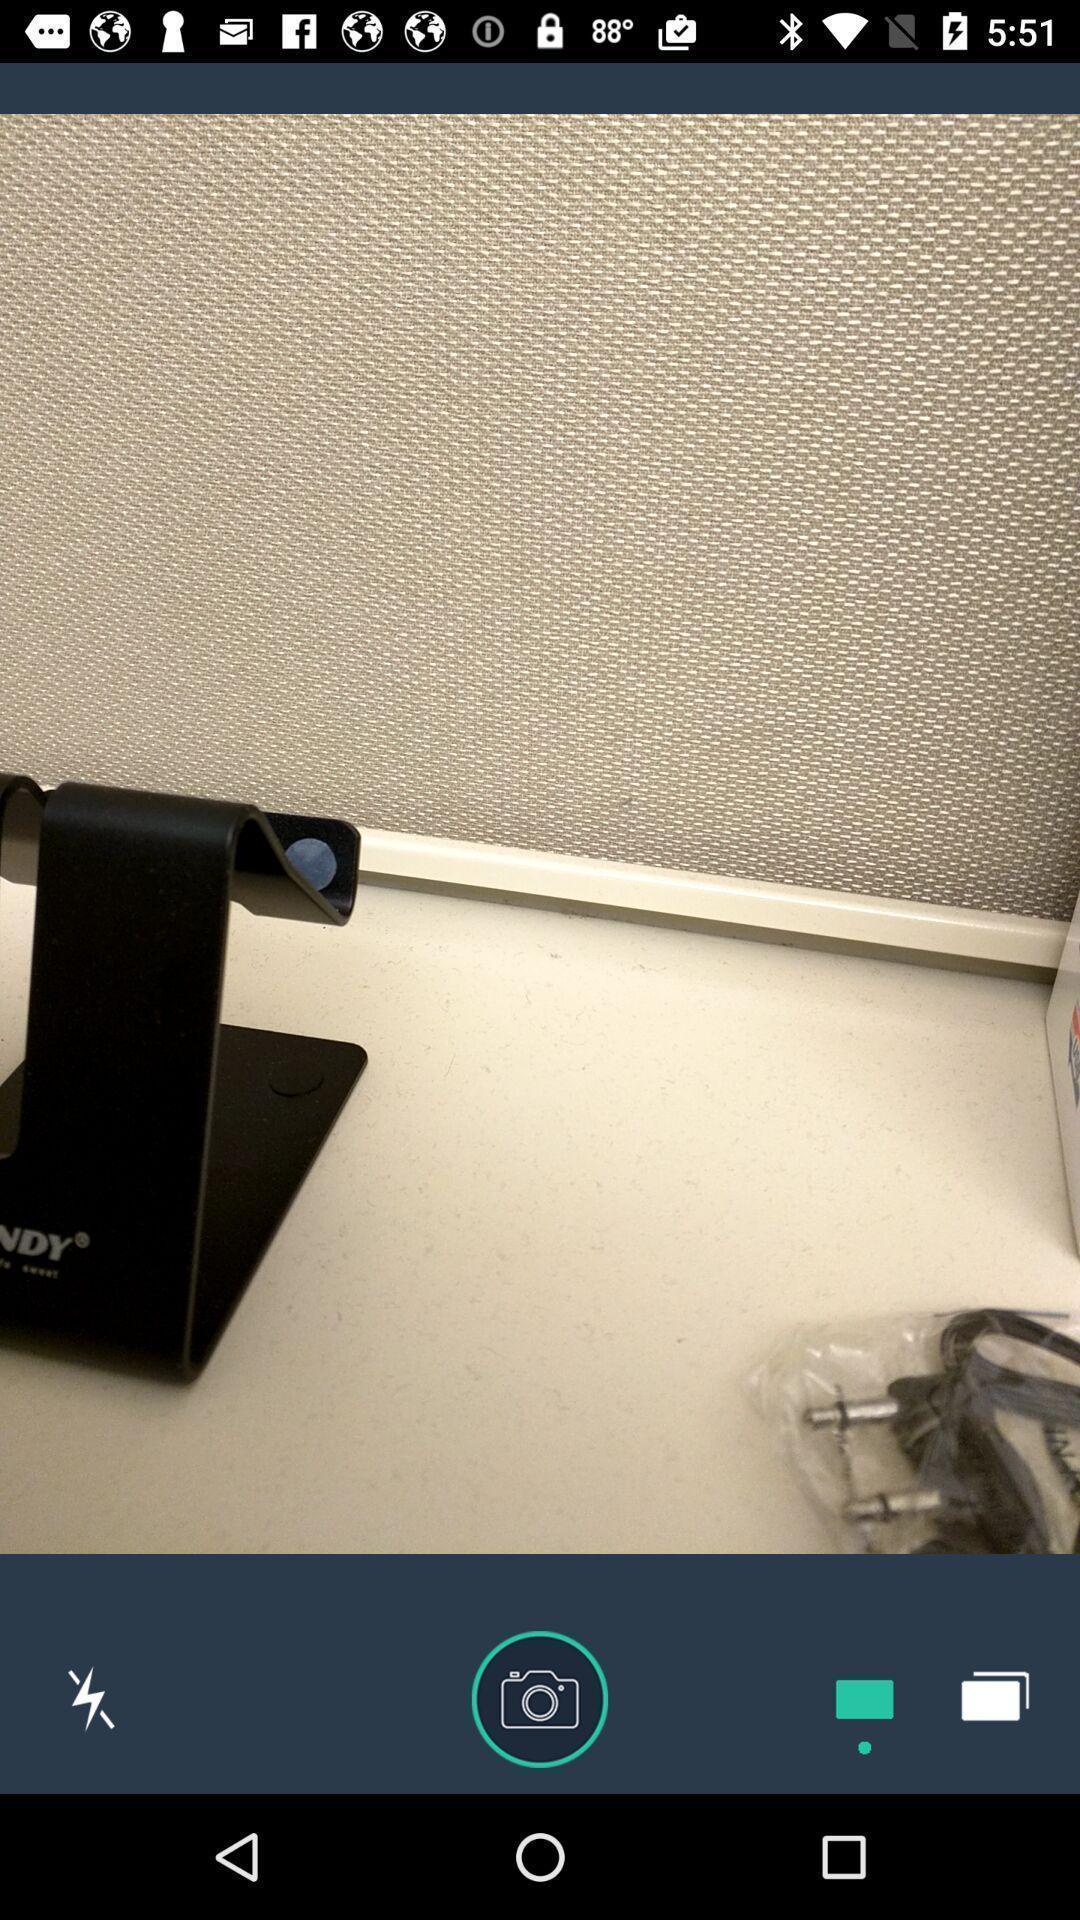Describe the key features of this screenshot. Screen shows an image with options. 